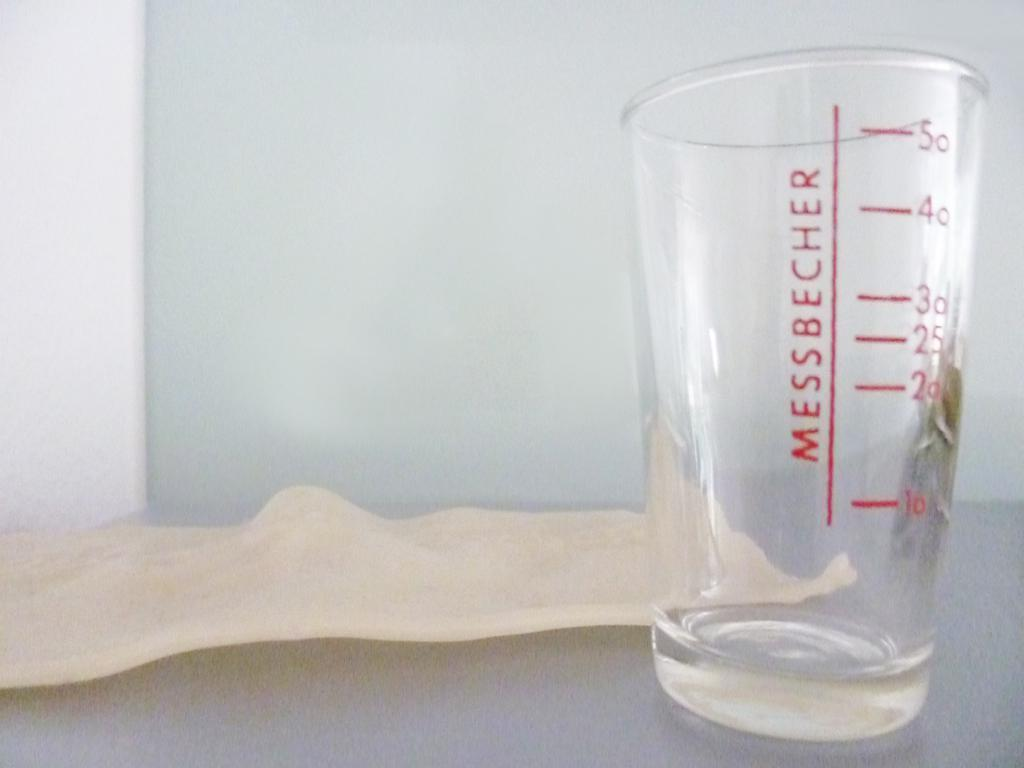<image>
Write a terse but informative summary of the picture. A cup with the measurements 10, 20, 35, 30, 40 and 50 